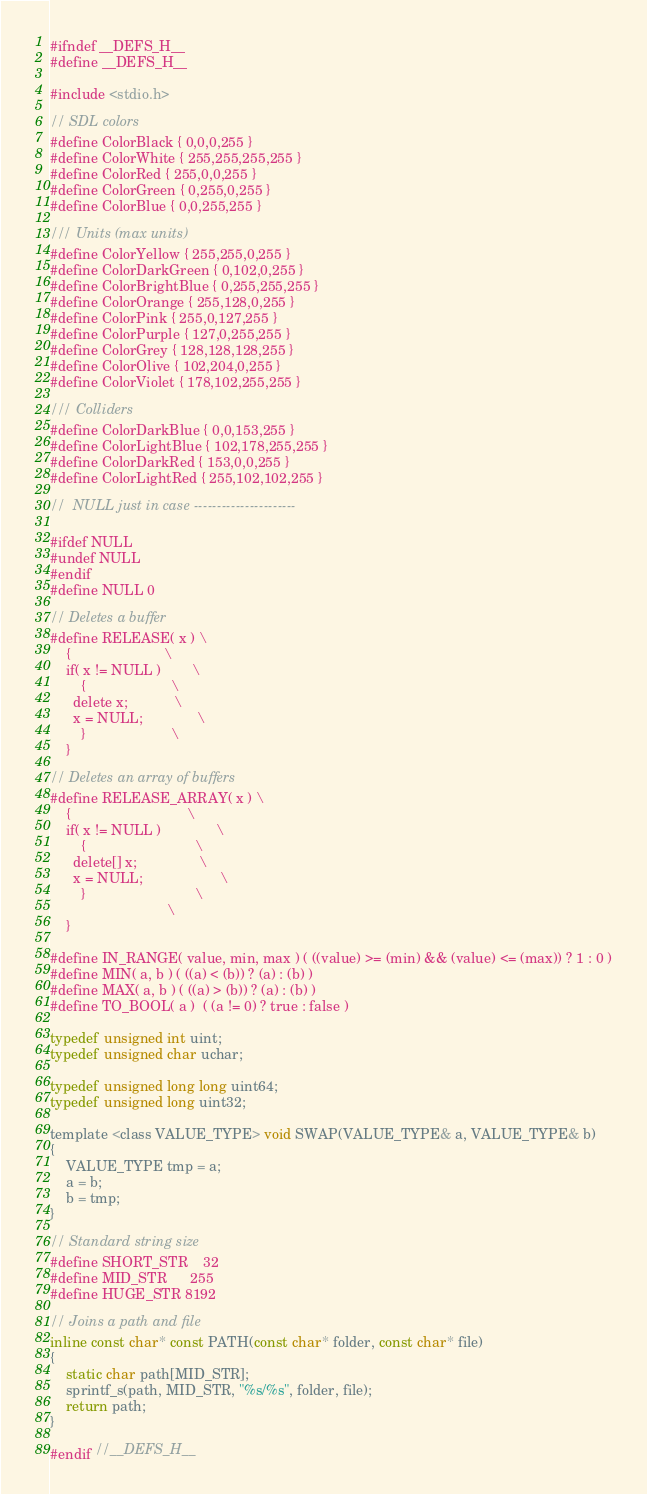<code> <loc_0><loc_0><loc_500><loc_500><_C_>#ifndef __DEFS_H__
#define __DEFS_H__

#include <stdio.h>

// SDL colors
#define ColorBlack { 0,0,0,255 }
#define ColorWhite { 255,255,255,255 }
#define ColorRed { 255,0,0,255 }
#define ColorGreen { 0,255,0,255 }
#define ColorBlue { 0,0,255,255 }

/// Units (max units)
#define ColorYellow { 255,255,0,255 }
#define ColorDarkGreen { 0,102,0,255 }
#define ColorBrightBlue { 0,255,255,255 }
#define ColorOrange { 255,128,0,255 }
#define ColorPink { 255,0,127,255 }
#define ColorPurple { 127,0,255,255 }
#define ColorGrey { 128,128,128,255 }
#define ColorOlive { 102,204,0,255 }
#define ColorViolet { 178,102,255,255 }

/// Colliders
#define ColorDarkBlue { 0,0,153,255 }
#define ColorLightBlue { 102,178,255,255 }
#define ColorDarkRed { 153,0,0,255 }
#define ColorLightRed { 255,102,102,255 }

//  NULL just in case ----------------------

#ifdef NULL
#undef NULL
#endif
#define NULL 0

// Deletes a buffer
#define RELEASE( x ) \
    {                        \
    if( x != NULL )        \
	    {                      \
      delete x;            \
	  x = NULL;              \
	    }                      \
    }

// Deletes an array of buffers
#define RELEASE_ARRAY( x ) \
    {                              \
    if( x != NULL )              \
	    {                            \
      delete[] x;                \
	  x = NULL;                    \
	    }                            \
                              \
    }

#define IN_RANGE( value, min, max ) ( ((value) >= (min) && (value) <= (max)) ? 1 : 0 )
#define MIN( a, b ) ( ((a) < (b)) ? (a) : (b) )
#define MAX( a, b ) ( ((a) > (b)) ? (a) : (b) )
#define TO_BOOL( a )  ( (a != 0) ? true : false )

typedef unsigned int uint;
typedef unsigned char uchar;

typedef unsigned long long uint64;
typedef unsigned long uint32;

template <class VALUE_TYPE> void SWAP(VALUE_TYPE& a, VALUE_TYPE& b)
{
	VALUE_TYPE tmp = a;
	a = b;
	b = tmp;
}

// Standard string size
#define SHORT_STR	32
#define MID_STR		255
#define HUGE_STR	8192

// Joins a path and file
inline const char* const PATH(const char* folder, const char* file)
{
	static char path[MID_STR];
	sprintf_s(path, MID_STR, "%s/%s", folder, file);
	return path;
}

#endif //__DEFS_H__</code> 